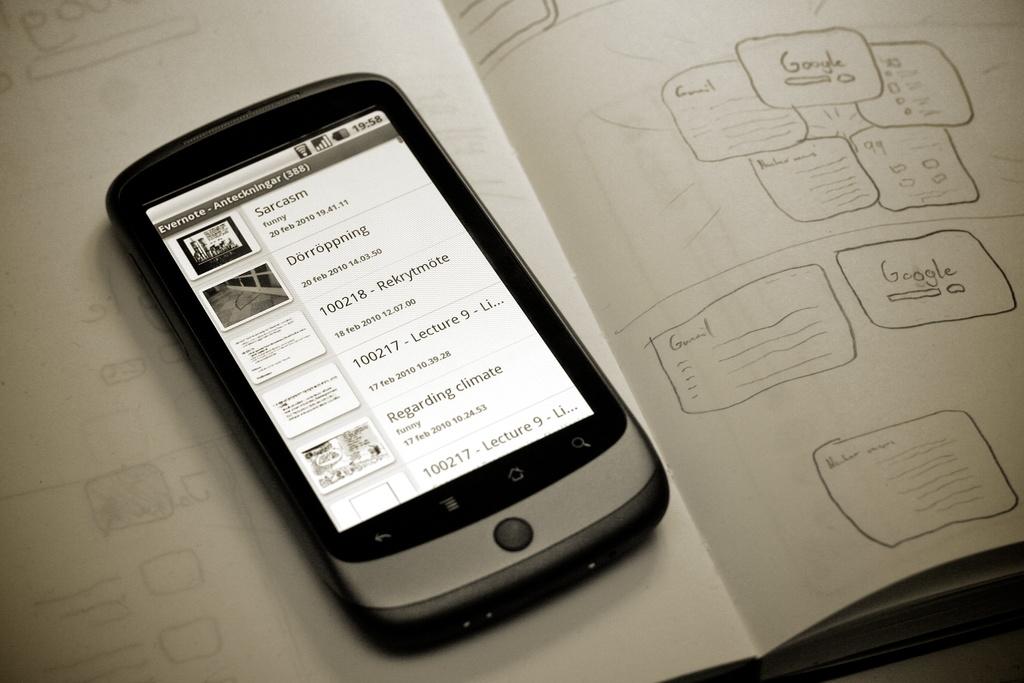What search engine was written on the paper?
Your answer should be compact. Google. What time does the clock say?
Provide a short and direct response. 19:58. 